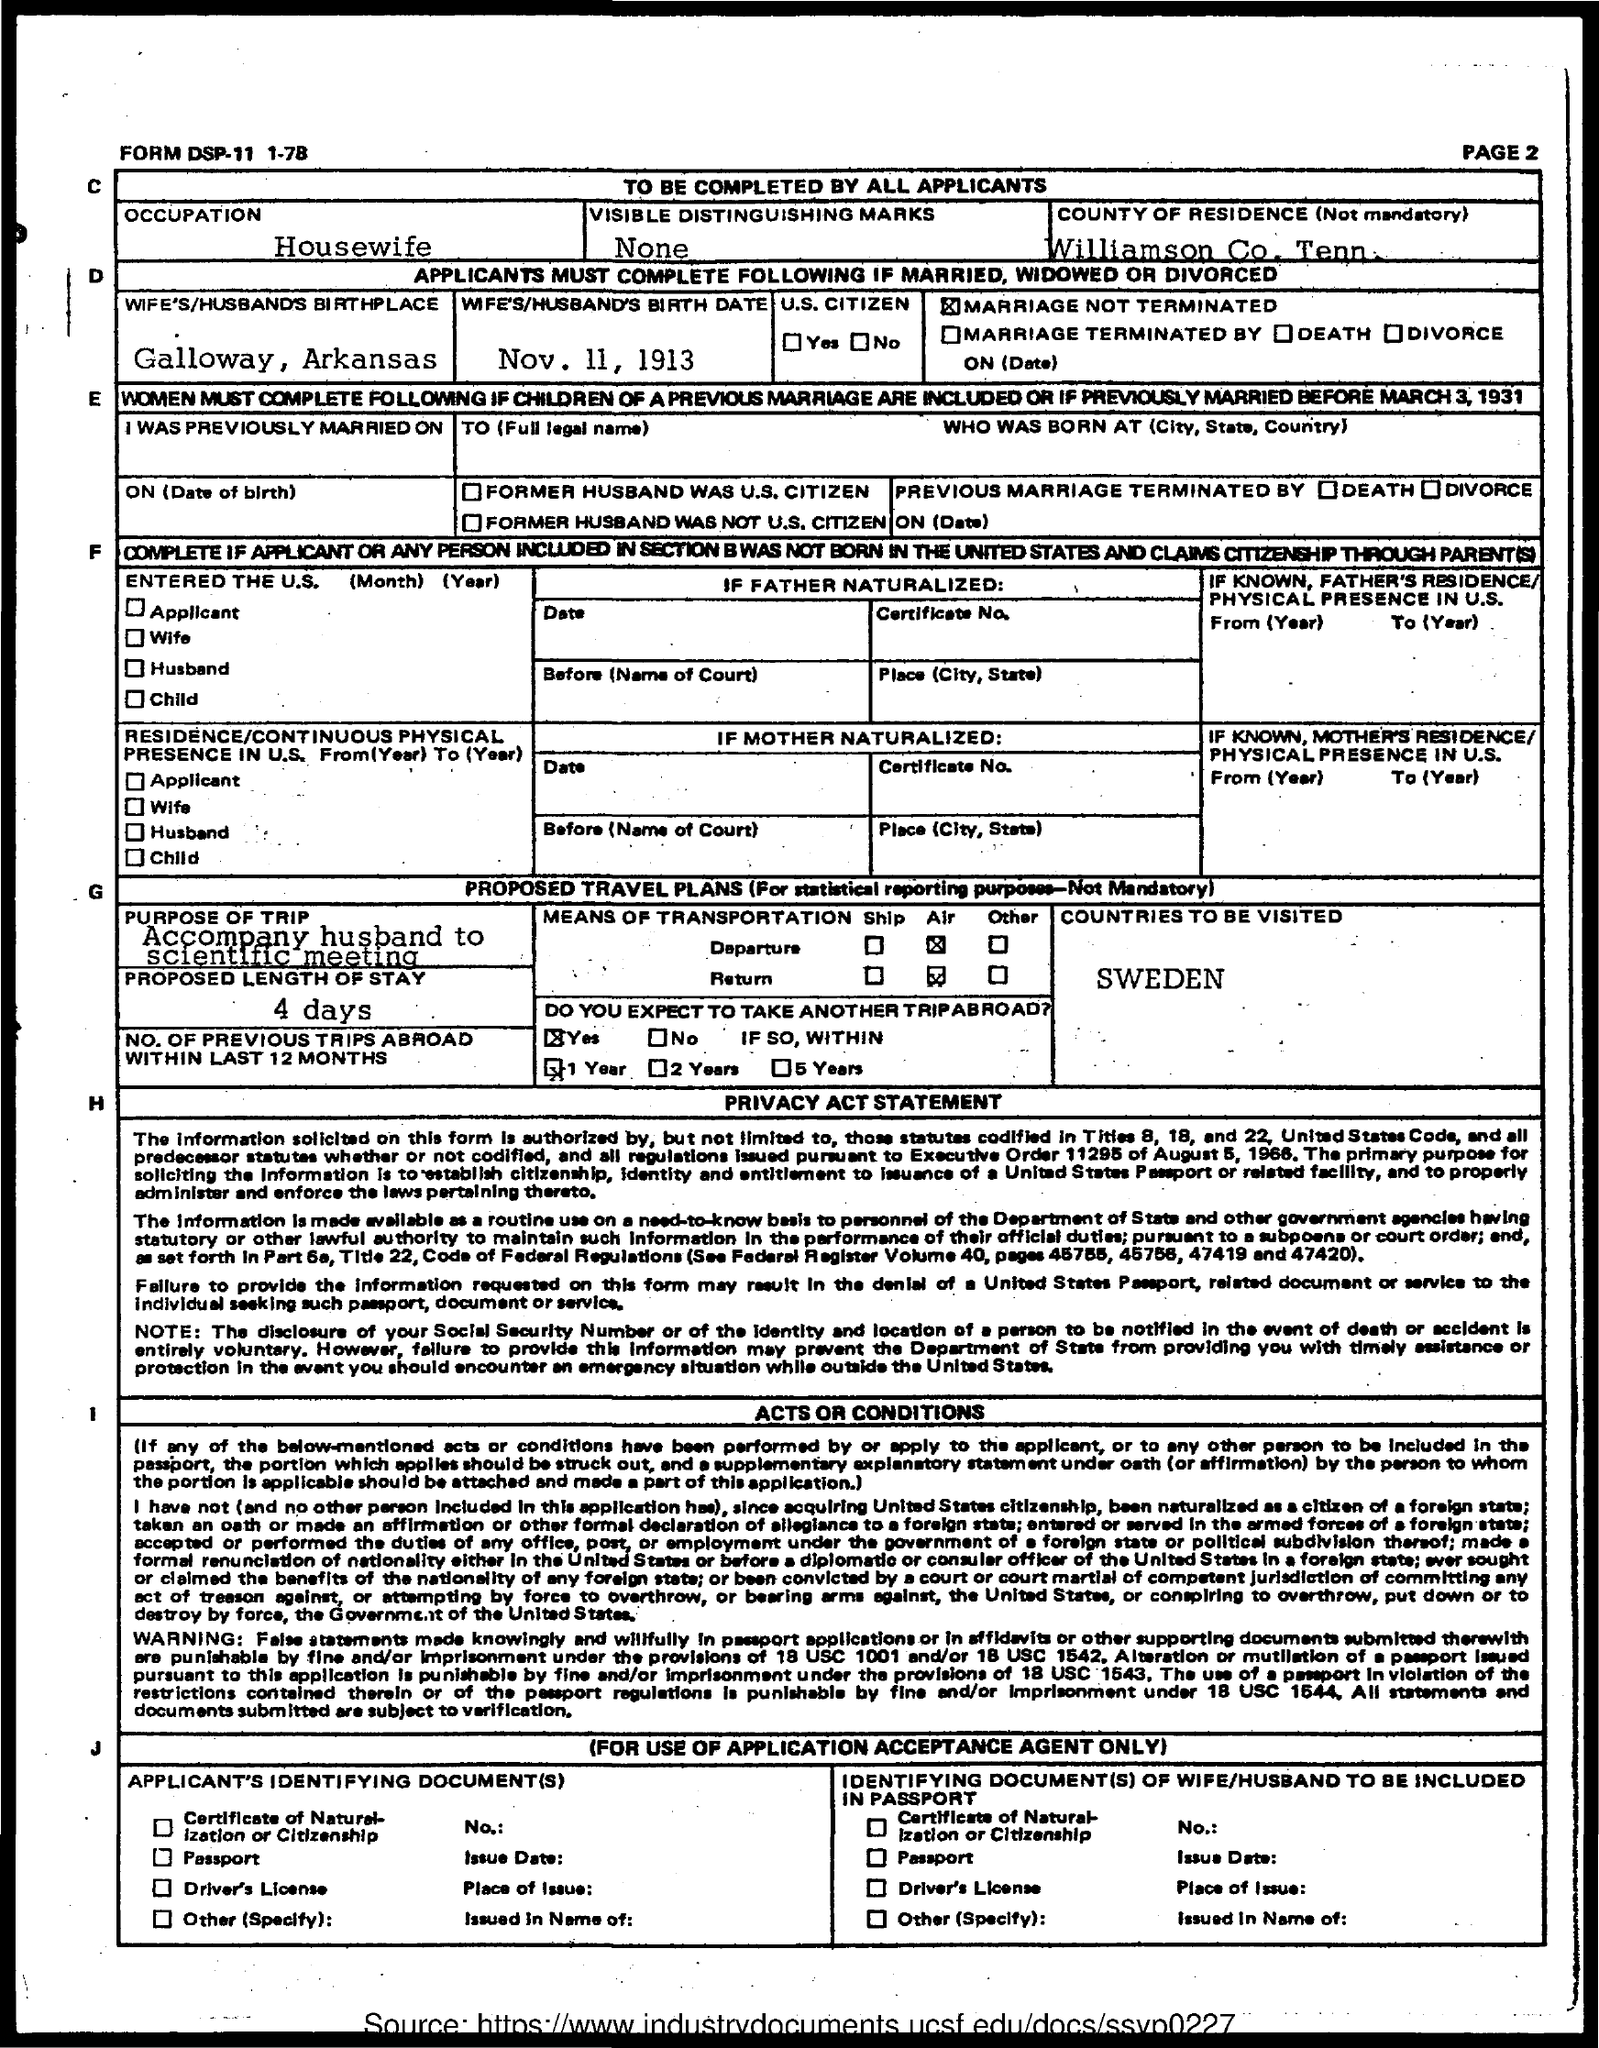What is the occupation mentioned in the given page ?
Provide a short and direct response. Housewife. What is the wife's / husband's birth date mentioned in the given form ?
Offer a terse response. Nov. 11, 1913. What is the purpose of the trip mentioned in the given form ?
Make the answer very short. Accompany husband to scientific meeting. What is the proposed length of stay as mentioned in the given form ?
Keep it short and to the point. 4 days. What are the name of the countries to be visited as mentioned in the given form ?
Give a very brief answer. Sweden. 